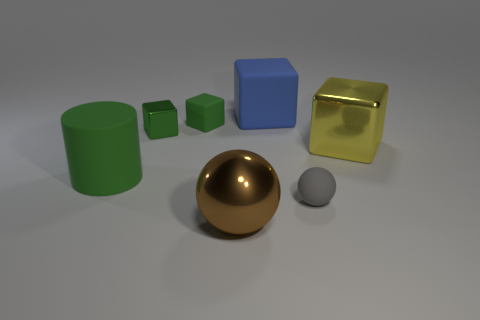Is the tiny matte block the same color as the small metal block?
Offer a terse response. Yes. What number of rubber spheres are the same color as the matte cylinder?
Provide a short and direct response. 0. Are there more big green rubber objects than tiny metallic balls?
Give a very brief answer. Yes. What size is the rubber thing that is both on the left side of the brown thing and in front of the tiny rubber cube?
Your answer should be compact. Large. Do the big thing that is on the left side of the brown thing and the yellow cube that is behind the large brown metal thing have the same material?
Give a very brief answer. No. What shape is the blue thing that is the same size as the yellow block?
Your answer should be very brief. Cube. Is the number of cyan metallic things less than the number of yellow shiny blocks?
Make the answer very short. Yes. There is a rubber thing that is in front of the matte cylinder; are there any matte cylinders right of it?
Your answer should be very brief. No. Is there a shiny object left of the large metallic object on the right side of the metal thing that is in front of the big yellow metal cube?
Your answer should be compact. Yes. Do the small rubber thing right of the blue matte block and the tiny rubber object behind the large cylinder have the same shape?
Give a very brief answer. No. 